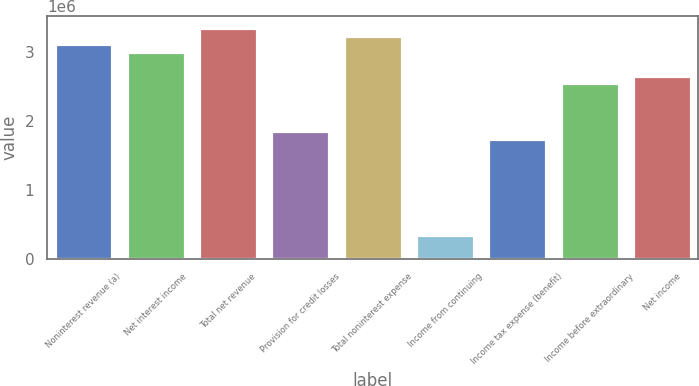Convert chart to OTSL. <chart><loc_0><loc_0><loc_500><loc_500><bar_chart><fcel>Noninterest revenue (a)<fcel>Net interest income<fcel>Total net revenue<fcel>Provision for credit losses<fcel>Total noninterest expense<fcel>Income from continuing<fcel>Income tax expense (benefit)<fcel>Income before extraordinary<fcel>Net income<nl><fcel>3.12457e+06<fcel>3.00884e+06<fcel>3.35602e+06<fcel>1.8516e+06<fcel>3.24029e+06<fcel>347175<fcel>1.73587e+06<fcel>2.54595e+06<fcel>2.66167e+06<nl></chart> 